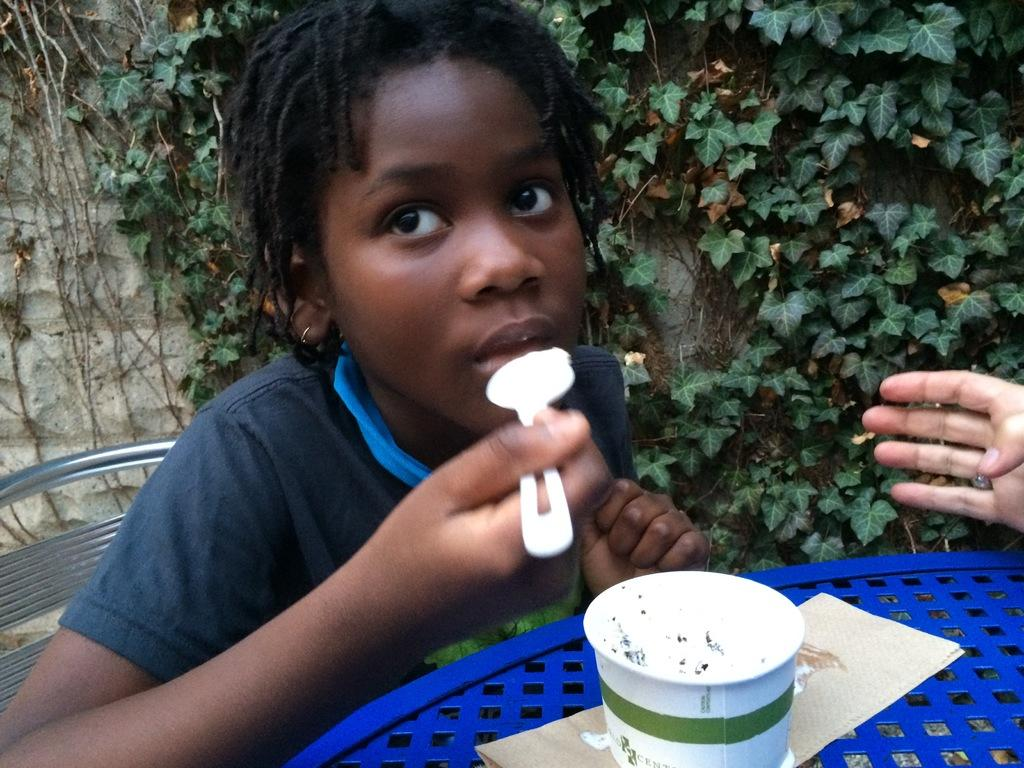Who is the main subject in the image? There is a girl in the image. What is the girl doing in the image? The girl is sitting and eating ice cream. Where is the ice cream placed in the image? The ice cream is placed on a table. How many sisters does the girl have in the image? There is no information about any sisters in the image. What type of bed is visible in the image? There is no bed present in the image. 